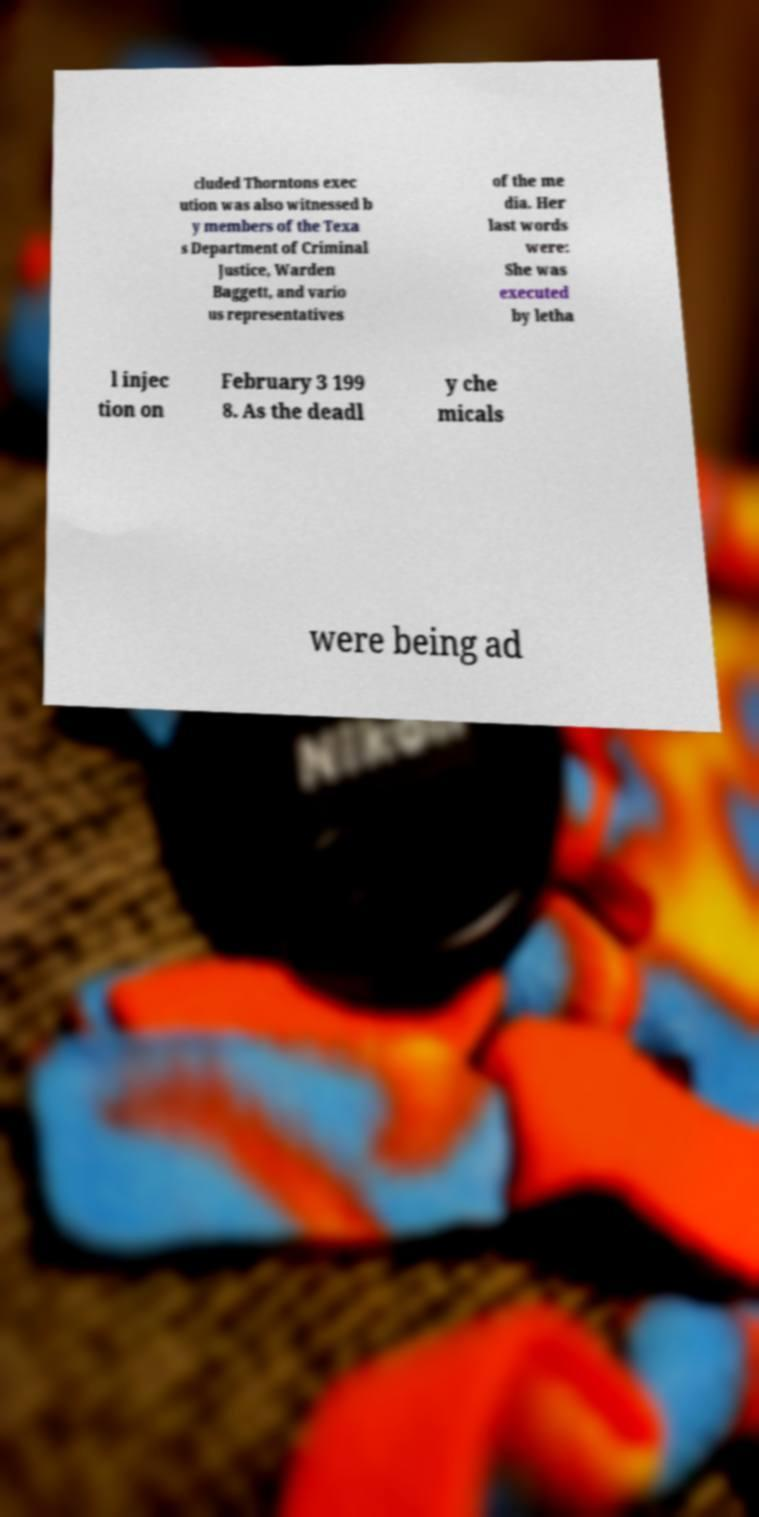There's text embedded in this image that I need extracted. Can you transcribe it verbatim? cluded Thorntons exec ution was also witnessed b y members of the Texa s Department of Criminal Justice, Warden Baggett, and vario us representatives of the me dia. Her last words were: She was executed by letha l injec tion on February 3 199 8. As the deadl y che micals were being ad 